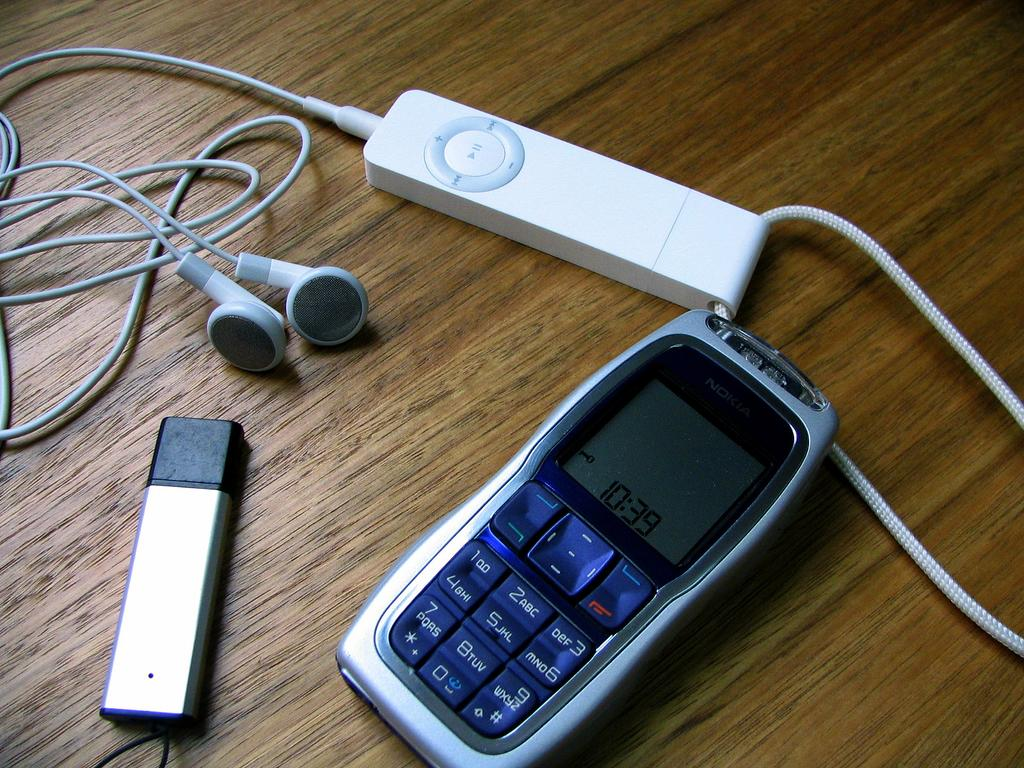What type of audio device is present in the image? There are earphones in the image. What device might be used to play music with the earphones? There is an iPod in the image that could be used to play music. What other electronic device is visible in the image? There is a mobile phone in the image. What is the surface on which the objects are placed? The objects are on a wooden floor. What type of agreement is being signed in the image? There is no agreement or signing activity present in the image. What type of lace can be seen on the floor in the image? There is no lace present on the wooden floor in the image. 